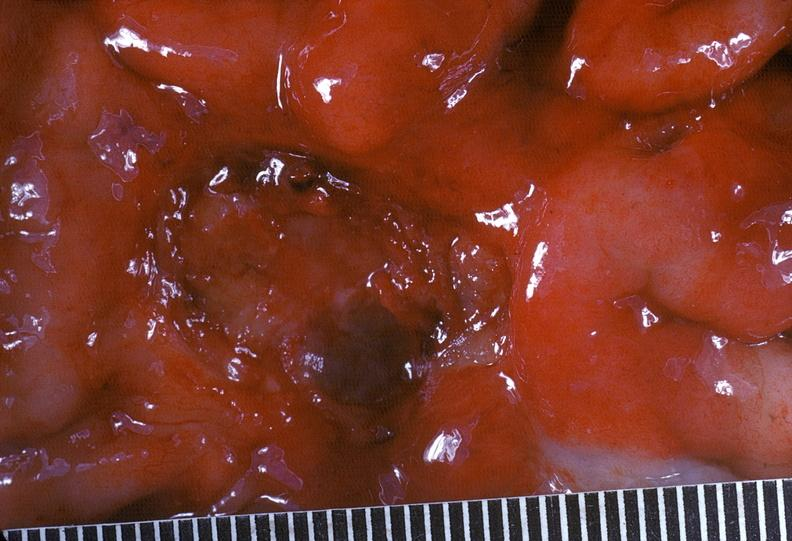s gastrointestinal present?
Answer the question using a single word or phrase. Yes 